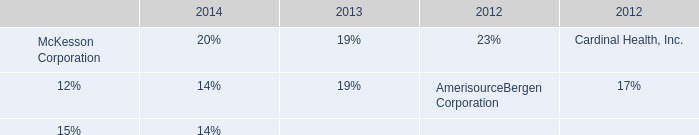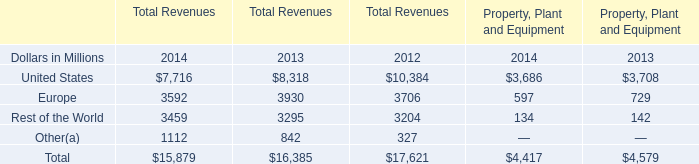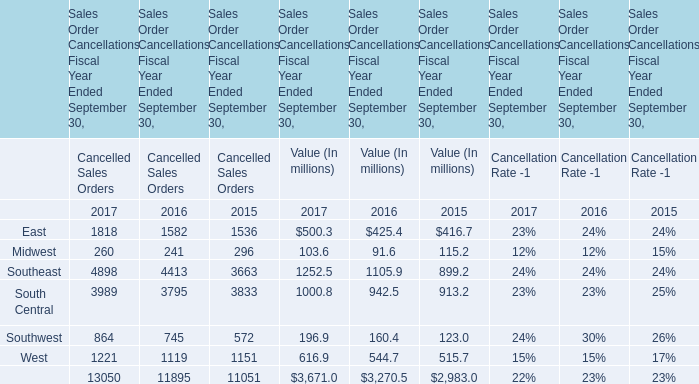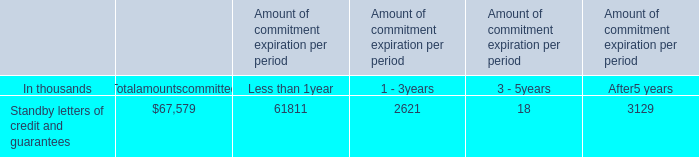How many years does East stay higher than Midwest in Value (In millions) ? 
Answer: 3. 